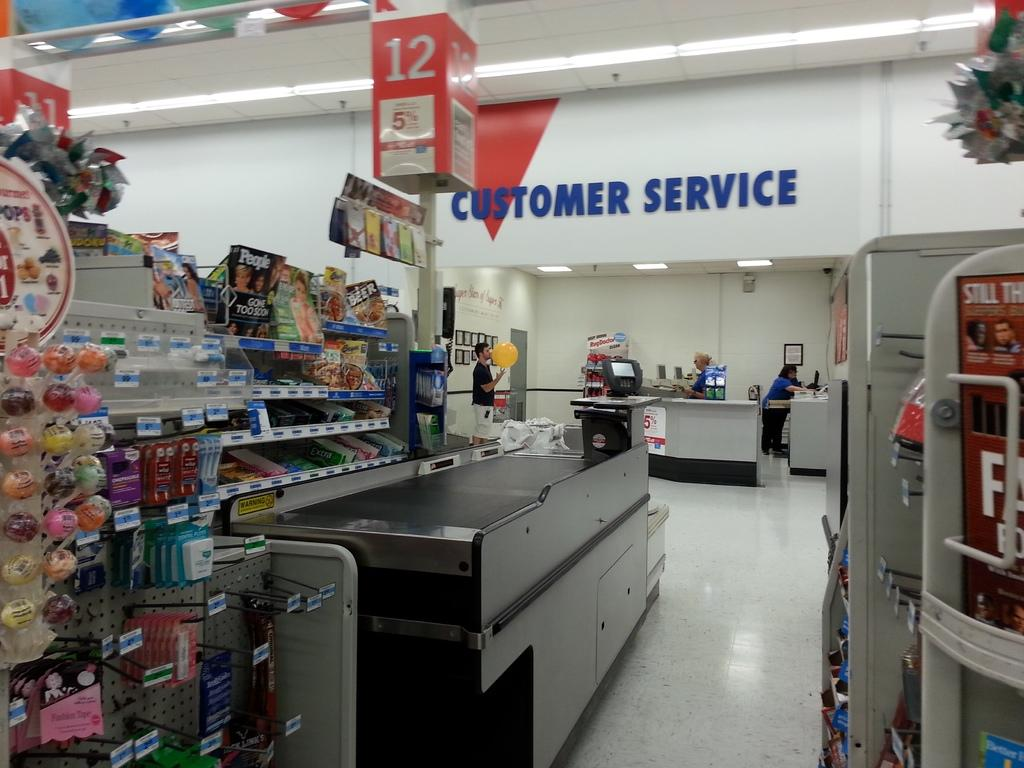<image>
Provide a brief description of the given image. A red arrow points to the customer service room. 